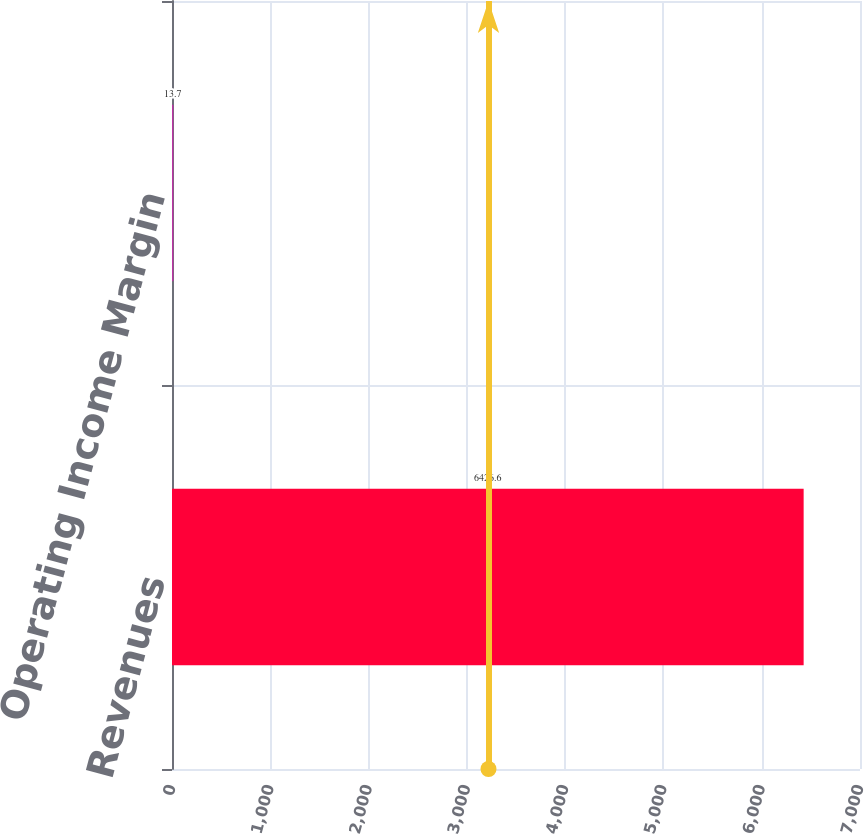<chart> <loc_0><loc_0><loc_500><loc_500><bar_chart><fcel>Revenues<fcel>Operating Income Margin<nl><fcel>6426.6<fcel>13.7<nl></chart> 